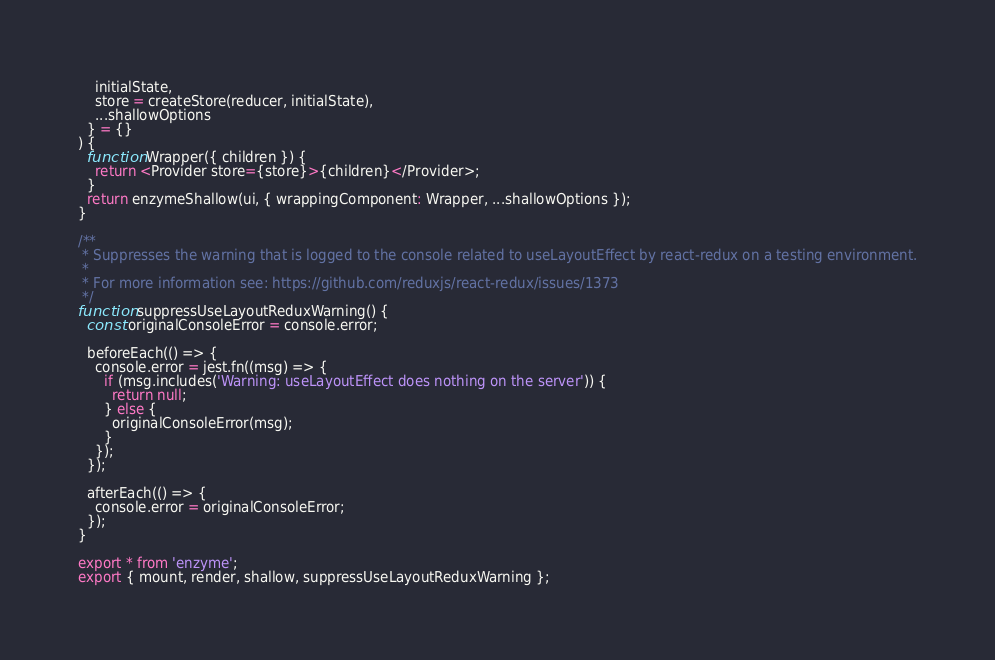Convert code to text. <code><loc_0><loc_0><loc_500><loc_500><_JavaScript_>    initialState,
    store = createStore(reducer, initialState),
    ...shallowOptions
  } = {}
) {
  function Wrapper({ children }) {
    return <Provider store={store}>{children}</Provider>;
  }
  return enzymeShallow(ui, { wrappingComponent: Wrapper, ...shallowOptions });
}

/**
 * Suppresses the warning that is logged to the console related to useLayoutEffect by react-redux on a testing environment.
 *
 * For more information see: https://github.com/reduxjs/react-redux/issues/1373
 */
function suppressUseLayoutReduxWarning() {
  const originalConsoleError = console.error;

  beforeEach(() => {
    console.error = jest.fn((msg) => {
      if (msg.includes('Warning: useLayoutEffect does nothing on the server')) {
        return null;
      } else {
        originalConsoleError(msg);
      }
    });
  });

  afterEach(() => {
    console.error = originalConsoleError;
  });
}

export * from 'enzyme';
export { mount, render, shallow, suppressUseLayoutReduxWarning };
</code> 